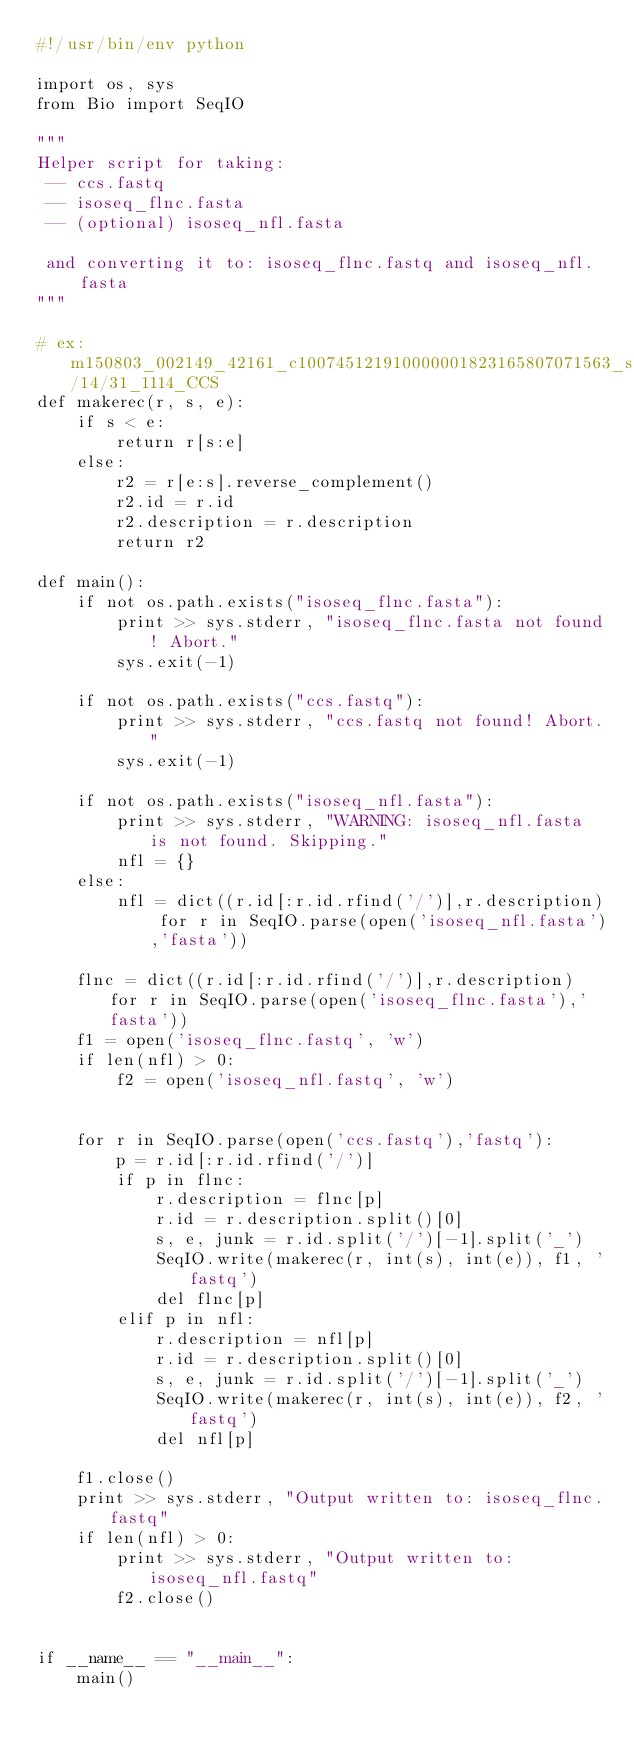<code> <loc_0><loc_0><loc_500><loc_500><_Python_>#!/usr/bin/env python

import os, sys
from Bio import SeqIO

"""
Helper script for taking:
 -- ccs.fastq
 -- isoseq_flnc.fasta
 -- (optional) isoseq_nfl.fasta

 and converting it to: isoseq_flnc.fastq and isoseq_nfl.fasta
"""

# ex: m150803_002149_42161_c100745121910000001823165807071563_s1_p0/14/31_1114_CCS
def makerec(r, s, e):
    if s < e:
        return r[s:e]
    else:
        r2 = r[e:s].reverse_complement()
        r2.id = r.id
        r2.description = r.description
        return r2

def main():
    if not os.path.exists("isoseq_flnc.fasta"):
        print >> sys.stderr, "isoseq_flnc.fasta not found! Abort."
        sys.exit(-1)

    if not os.path.exists("ccs.fastq"):
        print >> sys.stderr, "ccs.fastq not found! Abort."
        sys.exit(-1)

    if not os.path.exists("isoseq_nfl.fasta"):
        print >> sys.stderr, "WARNING: isoseq_nfl.fasta is not found. Skipping."
        nfl = {}
    else:
        nfl = dict((r.id[:r.id.rfind('/')],r.description) for r in SeqIO.parse(open('isoseq_nfl.fasta'),'fasta'))

    flnc = dict((r.id[:r.id.rfind('/')],r.description) for r in SeqIO.parse(open('isoseq_flnc.fasta'),'fasta'))
    f1 = open('isoseq_flnc.fastq', 'w')
    if len(nfl) > 0:
        f2 = open('isoseq_nfl.fastq', 'w')


    for r in SeqIO.parse(open('ccs.fastq'),'fastq'):
        p = r.id[:r.id.rfind('/')]
        if p in flnc:
            r.description = flnc[p]
            r.id = r.description.split()[0]
            s, e, junk = r.id.split('/')[-1].split('_')
            SeqIO.write(makerec(r, int(s), int(e)), f1, 'fastq')
            del flnc[p]
        elif p in nfl:
            r.description = nfl[p]
            r.id = r.description.split()[0]
            s, e, junk = r.id.split('/')[-1].split('_')
            SeqIO.write(makerec(r, int(s), int(e)), f2, 'fastq')
            del nfl[p]

    f1.close()
    print >> sys.stderr, "Output written to: isoseq_flnc.fastq"
    if len(nfl) > 0:
        print >> sys.stderr, "Output written to: isoseq_nfl.fastq"
        f2.close()


if __name__ == "__main__":
    main()





</code> 